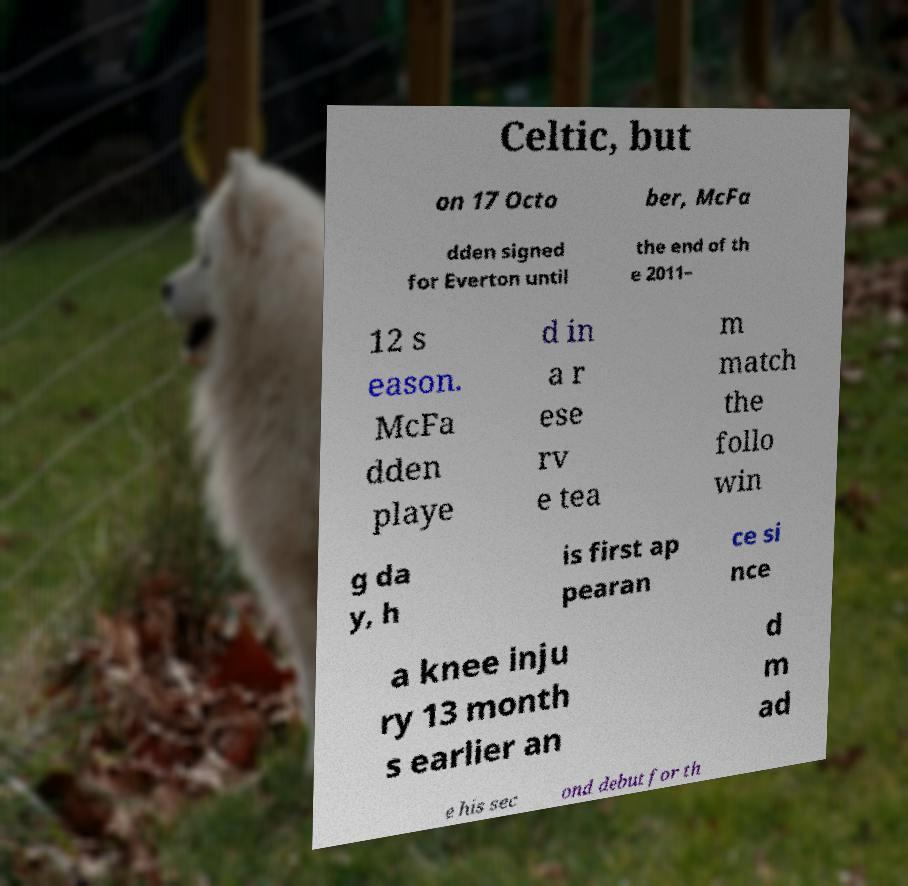Please identify and transcribe the text found in this image. Celtic, but on 17 Octo ber, McFa dden signed for Everton until the end of th e 2011– 12 s eason. McFa dden playe d in a r ese rv e tea m match the follo win g da y, h is first ap pearan ce si nce a knee inju ry 13 month s earlier an d m ad e his sec ond debut for th 